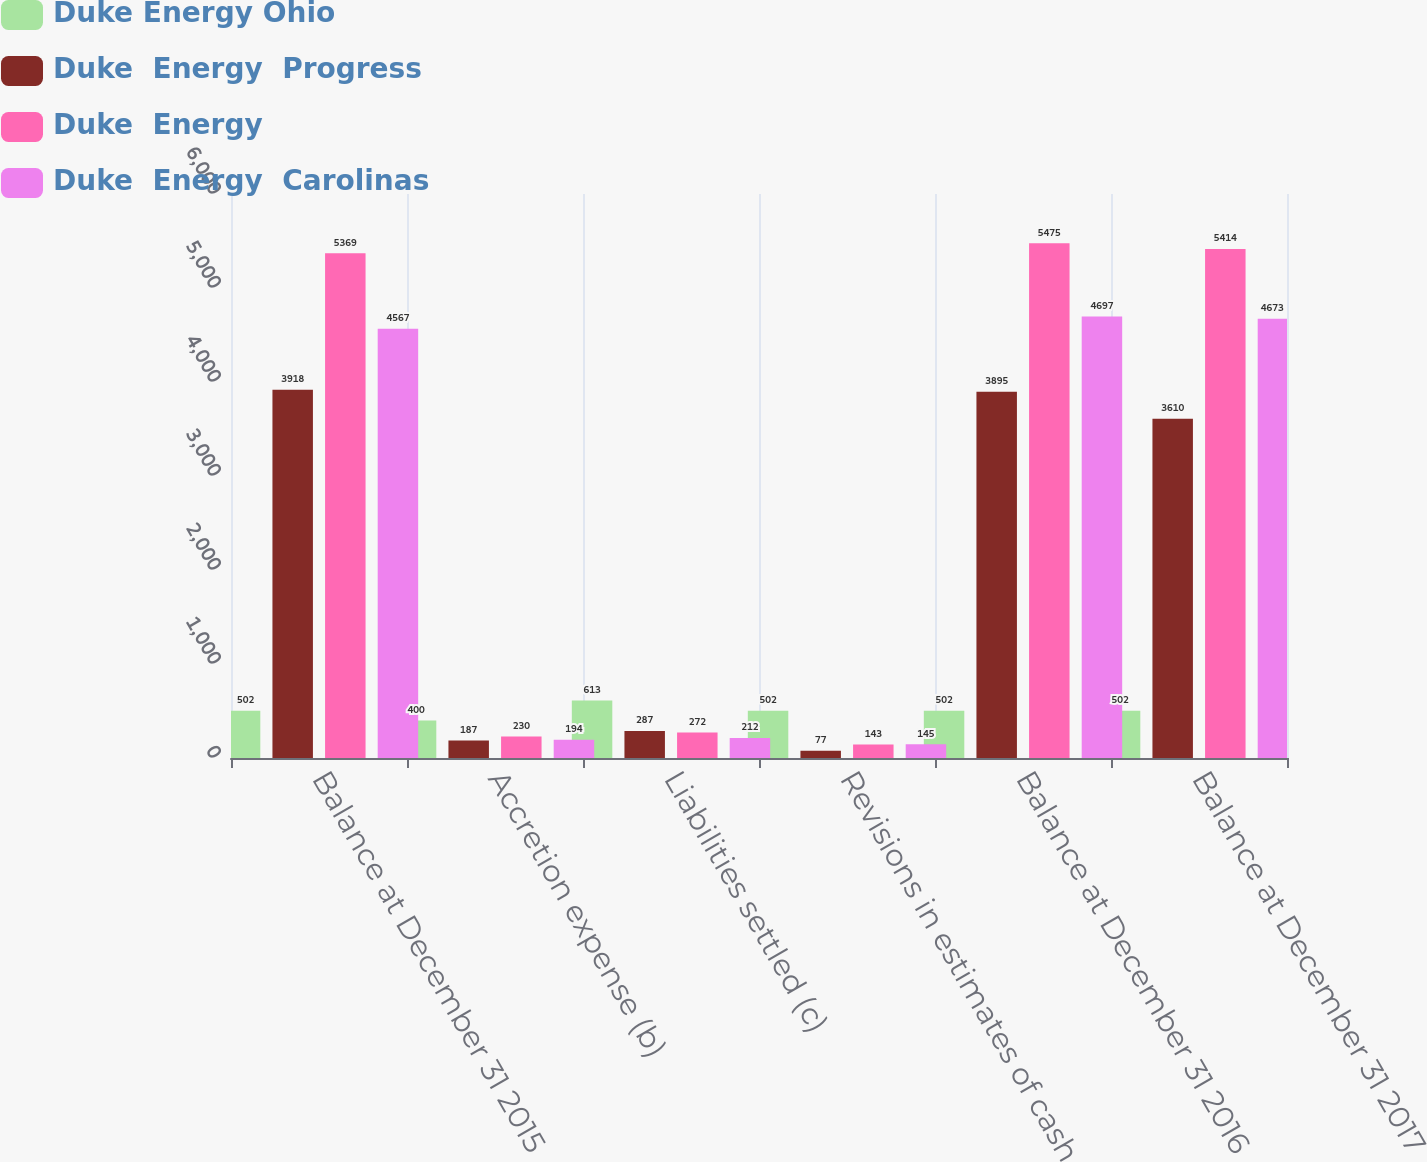Convert chart to OTSL. <chart><loc_0><loc_0><loc_500><loc_500><stacked_bar_chart><ecel><fcel>Balance at December 31 2015<fcel>Accretion expense (b)<fcel>Liabilities settled (c)<fcel>Revisions in estimates of cash<fcel>Balance at December 31 2016<fcel>Balance at December 31 2017<nl><fcel>Duke Energy Ohio<fcel>502<fcel>400<fcel>613<fcel>502<fcel>502<fcel>502<nl><fcel>Duke  Energy  Progress<fcel>3918<fcel>187<fcel>287<fcel>77<fcel>3895<fcel>3610<nl><fcel>Duke  Energy<fcel>5369<fcel>230<fcel>272<fcel>143<fcel>5475<fcel>5414<nl><fcel>Duke  Energy  Carolinas<fcel>4567<fcel>194<fcel>212<fcel>145<fcel>4697<fcel>4673<nl></chart> 